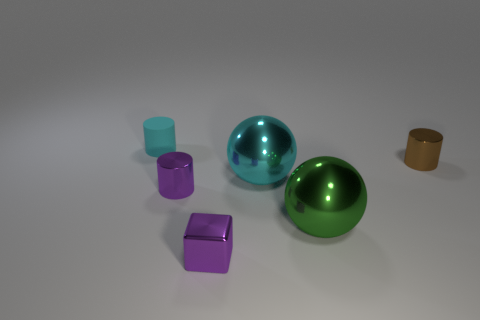Are there fewer tiny cyan matte objects that are in front of the large green object than small purple cylinders behind the large cyan thing?
Your answer should be compact. No. What size is the sphere that is in front of the big cyan shiny object?
Ensure brevity in your answer.  Large. The metal ball that is the same color as the small rubber cylinder is what size?
Give a very brief answer. Large. Are there any cyan things that have the same material as the tiny cyan cylinder?
Your answer should be very brief. No. Is the material of the large green ball the same as the small cyan cylinder?
Give a very brief answer. No. The other metal ball that is the same size as the cyan shiny sphere is what color?
Keep it short and to the point. Green. What number of other things are the same shape as the rubber object?
Your response must be concise. 2. Do the brown shiny thing and the metallic thing that is left of the tiny purple block have the same size?
Make the answer very short. Yes. How many things are big cyan cylinders or cylinders?
Make the answer very short. 3. How many other things are the same size as the purple block?
Give a very brief answer. 3. 